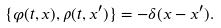<formula> <loc_0><loc_0><loc_500><loc_500>\{ \varphi ( t , { x } ) , \rho ( t , { x } ^ { \prime } ) \} = - \delta ( { x } - { x } ^ { \prime } ) .</formula> 